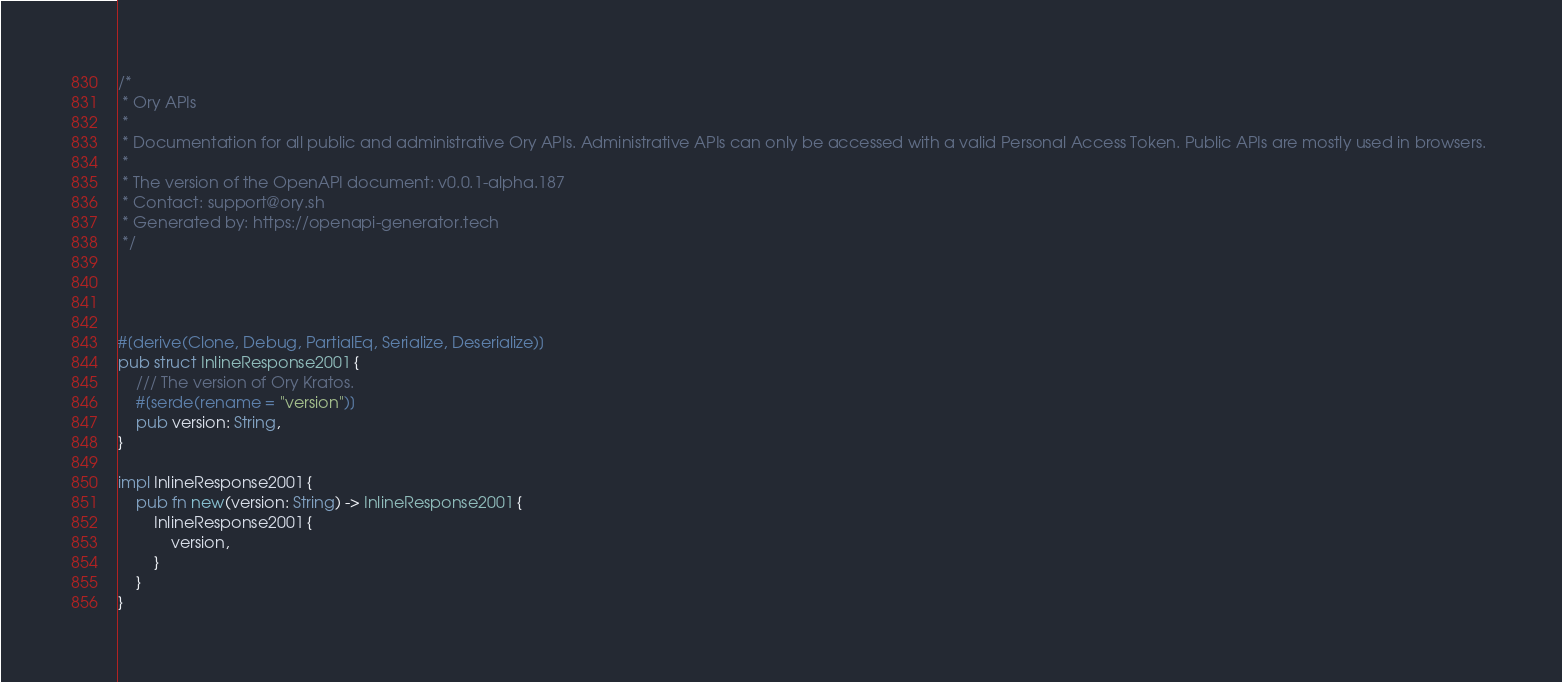<code> <loc_0><loc_0><loc_500><loc_500><_Rust_>/*
 * Ory APIs
 *
 * Documentation for all public and administrative Ory APIs. Administrative APIs can only be accessed with a valid Personal Access Token. Public APIs are mostly used in browsers. 
 *
 * The version of the OpenAPI document: v0.0.1-alpha.187
 * Contact: support@ory.sh
 * Generated by: https://openapi-generator.tech
 */




#[derive(Clone, Debug, PartialEq, Serialize, Deserialize)]
pub struct InlineResponse2001 {
    /// The version of Ory Kratos.
    #[serde(rename = "version")]
    pub version: String,
}

impl InlineResponse2001 {
    pub fn new(version: String) -> InlineResponse2001 {
        InlineResponse2001 {
            version,
        }
    }
}


</code> 